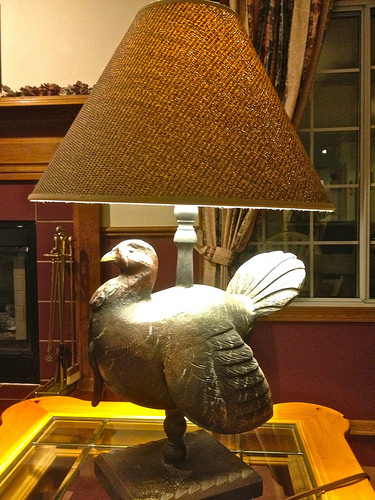<image>
Can you confirm if the turkey is under the lamp? Yes. The turkey is positioned underneath the lamp, with the lamp above it in the vertical space. 